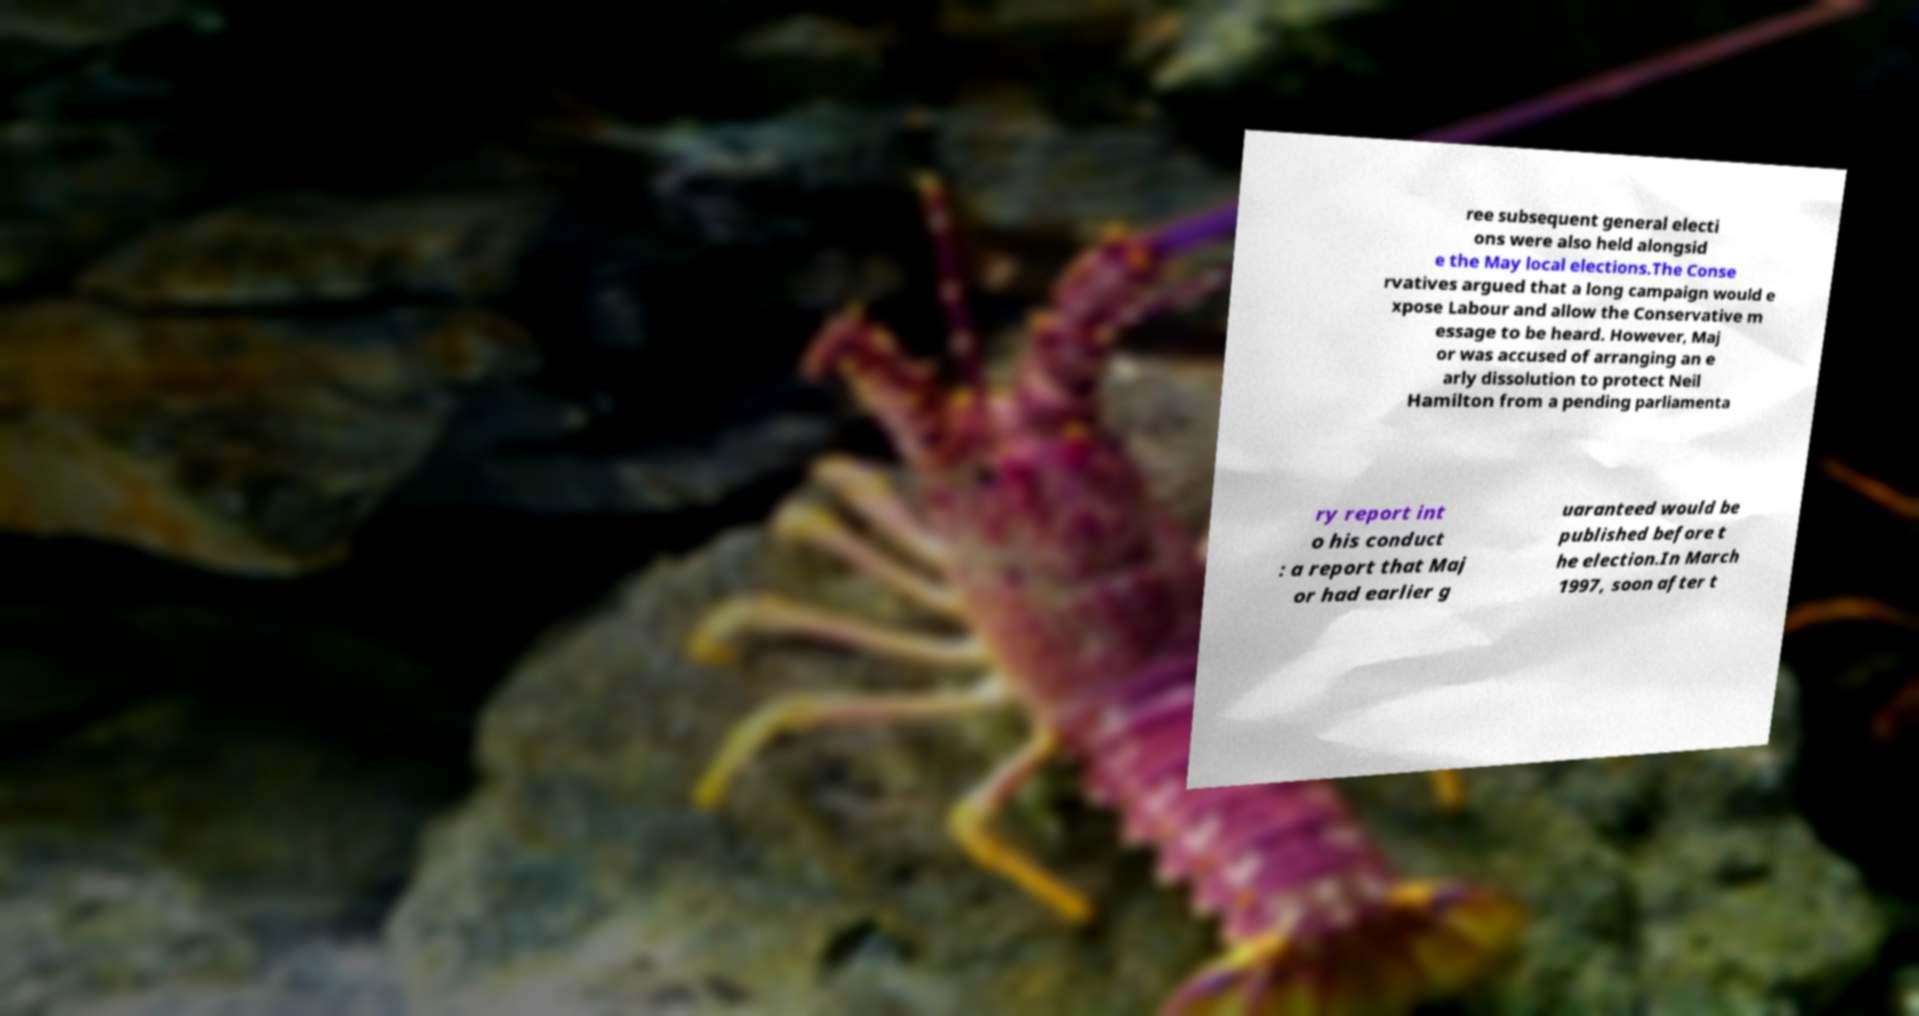I need the written content from this picture converted into text. Can you do that? ree subsequent general electi ons were also held alongsid e the May local elections.The Conse rvatives argued that a long campaign would e xpose Labour and allow the Conservative m essage to be heard. However, Maj or was accused of arranging an e arly dissolution to protect Neil Hamilton from a pending parliamenta ry report int o his conduct : a report that Maj or had earlier g uaranteed would be published before t he election.In March 1997, soon after t 